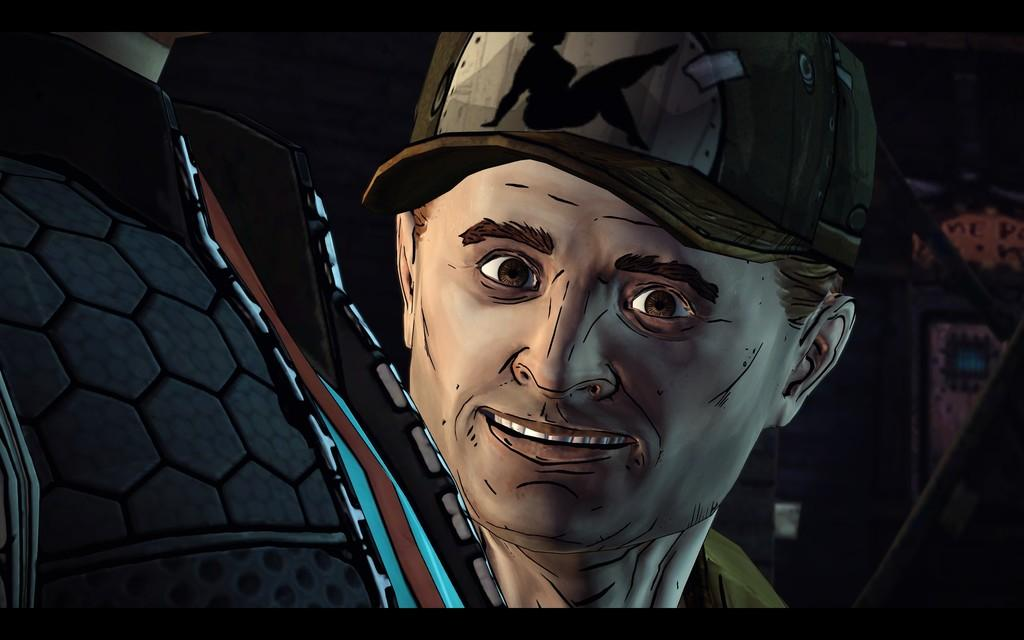What is depicted in the painting in the image? There is a painting of a person's face in the image. What is the person in the painting wearing on their head? The person in the painting is wearing a cap. Who else can be seen in the image besides the person in the painting? There is another person on the left side of the image. What type of clothing is the person on the left side of the image wearing? The person on the left side of the image is wearing some dress. What type of question is being asked in the image? There is no question being asked in the image; it features a painting and another person. Can you see any cherries in the image? There are no cherries present in the image. 